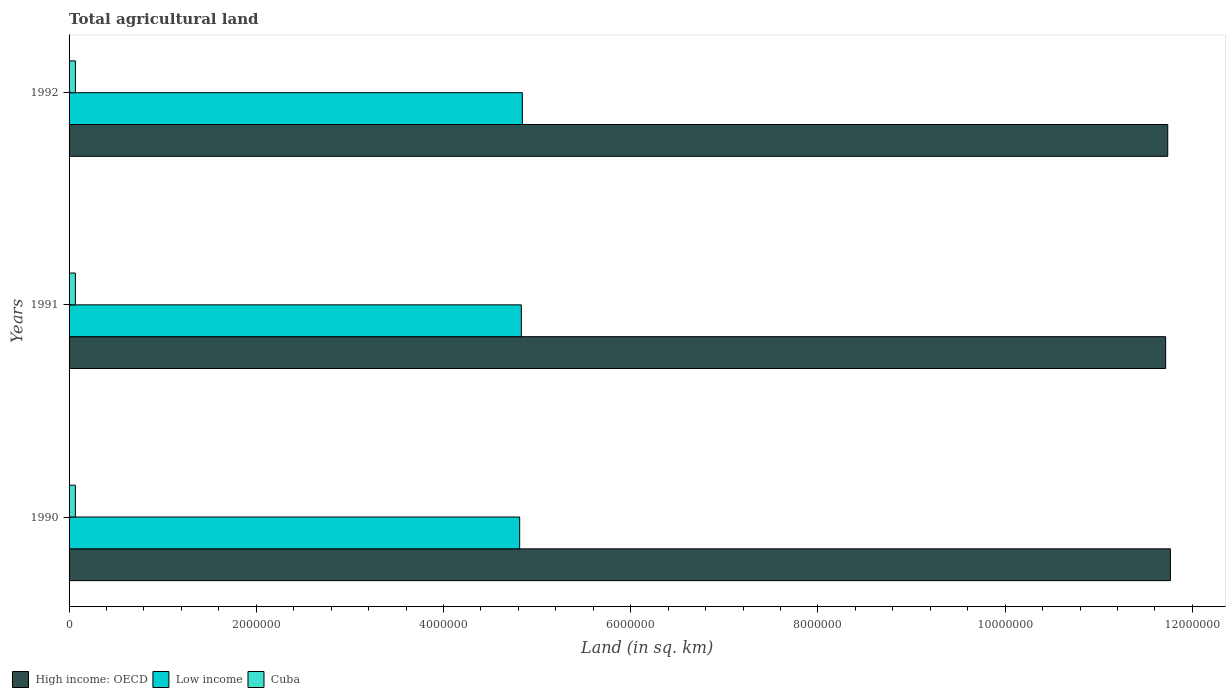How many different coloured bars are there?
Provide a succinct answer. 3. Are the number of bars on each tick of the Y-axis equal?
Offer a terse response. Yes. In how many cases, is the number of bars for a given year not equal to the number of legend labels?
Your response must be concise. 0. What is the total agricultural land in Cuba in 1990?
Your answer should be compact. 6.74e+04. Across all years, what is the maximum total agricultural land in High income: OECD?
Ensure brevity in your answer.  1.18e+07. Across all years, what is the minimum total agricultural land in Low income?
Keep it short and to the point. 4.81e+06. In which year was the total agricultural land in Low income minimum?
Your answer should be very brief. 1990. What is the total total agricultural land in Cuba in the graph?
Provide a short and direct response. 2.03e+05. What is the difference between the total agricultural land in Cuba in 1990 and that in 1992?
Your response must be concise. -340. What is the difference between the total agricultural land in Low income in 1990 and the total agricultural land in High income: OECD in 1992?
Make the answer very short. -6.92e+06. What is the average total agricultural land in Cuba per year?
Offer a terse response. 6.76e+04. In the year 1990, what is the difference between the total agricultural land in High income: OECD and total agricultural land in Low income?
Offer a terse response. 6.95e+06. In how many years, is the total agricultural land in High income: OECD greater than 800000 sq.km?
Offer a terse response. 3. What is the ratio of the total agricultural land in Cuba in 1990 to that in 1991?
Keep it short and to the point. 1. What is the difference between the highest and the second highest total agricultural land in Low income?
Make the answer very short. 1.09e+04. What is the difference between the highest and the lowest total agricultural land in Low income?
Your response must be concise. 2.87e+04. In how many years, is the total agricultural land in High income: OECD greater than the average total agricultural land in High income: OECD taken over all years?
Keep it short and to the point. 1. Is the sum of the total agricultural land in High income: OECD in 1990 and 1992 greater than the maximum total agricultural land in Low income across all years?
Your response must be concise. Yes. What does the 3rd bar from the top in 1990 represents?
Offer a very short reply. High income: OECD. What does the 2nd bar from the bottom in 1992 represents?
Make the answer very short. Low income. How many bars are there?
Provide a short and direct response. 9. Does the graph contain any zero values?
Your answer should be compact. No. Where does the legend appear in the graph?
Your answer should be very brief. Bottom left. How many legend labels are there?
Your answer should be very brief. 3. What is the title of the graph?
Offer a terse response. Total agricultural land. What is the label or title of the X-axis?
Offer a terse response. Land (in sq. km). What is the Land (in sq. km) in High income: OECD in 1990?
Give a very brief answer. 1.18e+07. What is the Land (in sq. km) of Low income in 1990?
Provide a succinct answer. 4.81e+06. What is the Land (in sq. km) of Cuba in 1990?
Your answer should be very brief. 6.74e+04. What is the Land (in sq. km) of High income: OECD in 1991?
Make the answer very short. 1.17e+07. What is the Land (in sq. km) in Low income in 1991?
Offer a very short reply. 4.83e+06. What is the Land (in sq. km) of Cuba in 1991?
Your answer should be compact. 6.76e+04. What is the Land (in sq. km) of High income: OECD in 1992?
Provide a succinct answer. 1.17e+07. What is the Land (in sq. km) of Low income in 1992?
Your answer should be very brief. 4.84e+06. What is the Land (in sq. km) of Cuba in 1992?
Offer a terse response. 6.78e+04. Across all years, what is the maximum Land (in sq. km) of High income: OECD?
Provide a short and direct response. 1.18e+07. Across all years, what is the maximum Land (in sq. km) in Low income?
Your response must be concise. 4.84e+06. Across all years, what is the maximum Land (in sq. km) in Cuba?
Make the answer very short. 6.78e+04. Across all years, what is the minimum Land (in sq. km) of High income: OECD?
Your answer should be very brief. 1.17e+07. Across all years, what is the minimum Land (in sq. km) of Low income?
Your answer should be compact. 4.81e+06. Across all years, what is the minimum Land (in sq. km) of Cuba?
Ensure brevity in your answer.  6.74e+04. What is the total Land (in sq. km) in High income: OECD in the graph?
Keep it short and to the point. 3.52e+07. What is the total Land (in sq. km) of Low income in the graph?
Your answer should be very brief. 1.45e+07. What is the total Land (in sq. km) of Cuba in the graph?
Ensure brevity in your answer.  2.03e+05. What is the difference between the Land (in sq. km) in High income: OECD in 1990 and that in 1991?
Your answer should be compact. 5.07e+04. What is the difference between the Land (in sq. km) in Low income in 1990 and that in 1991?
Offer a terse response. -1.77e+04. What is the difference between the Land (in sq. km) of Cuba in 1990 and that in 1991?
Provide a short and direct response. -140. What is the difference between the Land (in sq. km) in High income: OECD in 1990 and that in 1992?
Your answer should be very brief. 2.87e+04. What is the difference between the Land (in sq. km) in Low income in 1990 and that in 1992?
Offer a very short reply. -2.87e+04. What is the difference between the Land (in sq. km) in Cuba in 1990 and that in 1992?
Keep it short and to the point. -340. What is the difference between the Land (in sq. km) of High income: OECD in 1991 and that in 1992?
Keep it short and to the point. -2.21e+04. What is the difference between the Land (in sq. km) of Low income in 1991 and that in 1992?
Ensure brevity in your answer.  -1.09e+04. What is the difference between the Land (in sq. km) of Cuba in 1991 and that in 1992?
Give a very brief answer. -200. What is the difference between the Land (in sq. km) in High income: OECD in 1990 and the Land (in sq. km) in Low income in 1991?
Ensure brevity in your answer.  6.93e+06. What is the difference between the Land (in sq. km) in High income: OECD in 1990 and the Land (in sq. km) in Cuba in 1991?
Provide a succinct answer. 1.17e+07. What is the difference between the Land (in sq. km) in Low income in 1990 and the Land (in sq. km) in Cuba in 1991?
Make the answer very short. 4.75e+06. What is the difference between the Land (in sq. km) in High income: OECD in 1990 and the Land (in sq. km) in Low income in 1992?
Make the answer very short. 6.92e+06. What is the difference between the Land (in sq. km) of High income: OECD in 1990 and the Land (in sq. km) of Cuba in 1992?
Make the answer very short. 1.17e+07. What is the difference between the Land (in sq. km) of Low income in 1990 and the Land (in sq. km) of Cuba in 1992?
Your response must be concise. 4.75e+06. What is the difference between the Land (in sq. km) in High income: OECD in 1991 and the Land (in sq. km) in Low income in 1992?
Make the answer very short. 6.87e+06. What is the difference between the Land (in sq. km) in High income: OECD in 1991 and the Land (in sq. km) in Cuba in 1992?
Offer a terse response. 1.16e+07. What is the difference between the Land (in sq. km) in Low income in 1991 and the Land (in sq. km) in Cuba in 1992?
Keep it short and to the point. 4.76e+06. What is the average Land (in sq. km) of High income: OECD per year?
Ensure brevity in your answer.  1.17e+07. What is the average Land (in sq. km) of Low income per year?
Give a very brief answer. 4.83e+06. What is the average Land (in sq. km) of Cuba per year?
Offer a very short reply. 6.76e+04. In the year 1990, what is the difference between the Land (in sq. km) in High income: OECD and Land (in sq. km) in Low income?
Keep it short and to the point. 6.95e+06. In the year 1990, what is the difference between the Land (in sq. km) of High income: OECD and Land (in sq. km) of Cuba?
Provide a succinct answer. 1.17e+07. In the year 1990, what is the difference between the Land (in sq. km) of Low income and Land (in sq. km) of Cuba?
Provide a succinct answer. 4.75e+06. In the year 1991, what is the difference between the Land (in sq. km) in High income: OECD and Land (in sq. km) in Low income?
Provide a succinct answer. 6.88e+06. In the year 1991, what is the difference between the Land (in sq. km) in High income: OECD and Land (in sq. km) in Cuba?
Your answer should be compact. 1.16e+07. In the year 1991, what is the difference between the Land (in sq. km) of Low income and Land (in sq. km) of Cuba?
Offer a terse response. 4.76e+06. In the year 1992, what is the difference between the Land (in sq. km) in High income: OECD and Land (in sq. km) in Low income?
Offer a terse response. 6.89e+06. In the year 1992, what is the difference between the Land (in sq. km) of High income: OECD and Land (in sq. km) of Cuba?
Your answer should be compact. 1.17e+07. In the year 1992, what is the difference between the Land (in sq. km) of Low income and Land (in sq. km) of Cuba?
Give a very brief answer. 4.77e+06. What is the ratio of the Land (in sq. km) in Cuba in 1990 to that in 1992?
Give a very brief answer. 0.99. What is the ratio of the Land (in sq. km) of Low income in 1991 to that in 1992?
Offer a very short reply. 1. What is the ratio of the Land (in sq. km) in Cuba in 1991 to that in 1992?
Provide a short and direct response. 1. What is the difference between the highest and the second highest Land (in sq. km) in High income: OECD?
Give a very brief answer. 2.87e+04. What is the difference between the highest and the second highest Land (in sq. km) in Low income?
Provide a short and direct response. 1.09e+04. What is the difference between the highest and the second highest Land (in sq. km) of Cuba?
Your answer should be compact. 200. What is the difference between the highest and the lowest Land (in sq. km) of High income: OECD?
Offer a terse response. 5.07e+04. What is the difference between the highest and the lowest Land (in sq. km) of Low income?
Offer a very short reply. 2.87e+04. What is the difference between the highest and the lowest Land (in sq. km) in Cuba?
Ensure brevity in your answer.  340. 